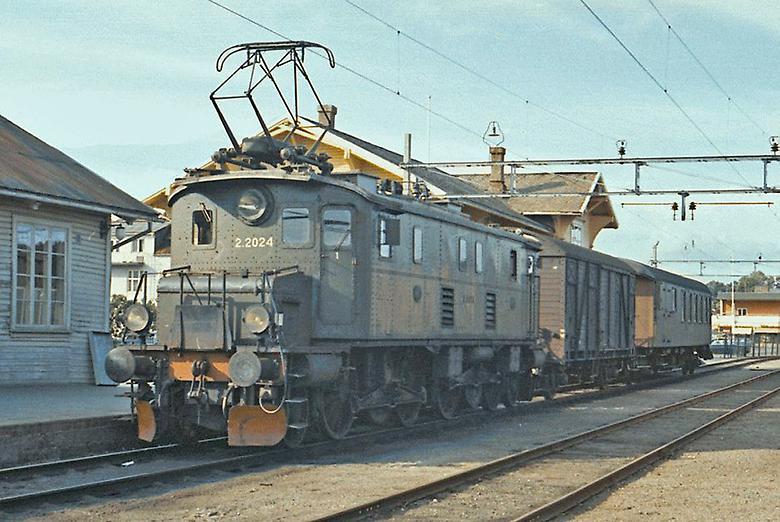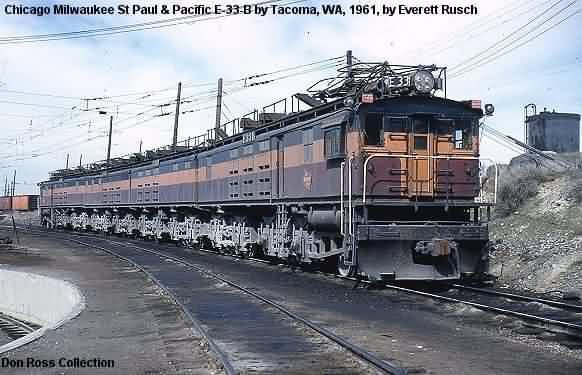The first image is the image on the left, the second image is the image on the right. Analyze the images presented: Is the assertion "The train in the right image has a slightly pitched top like a peaked roof and has at least two distinct colors that run its length." valid? Answer yes or no. Yes. 